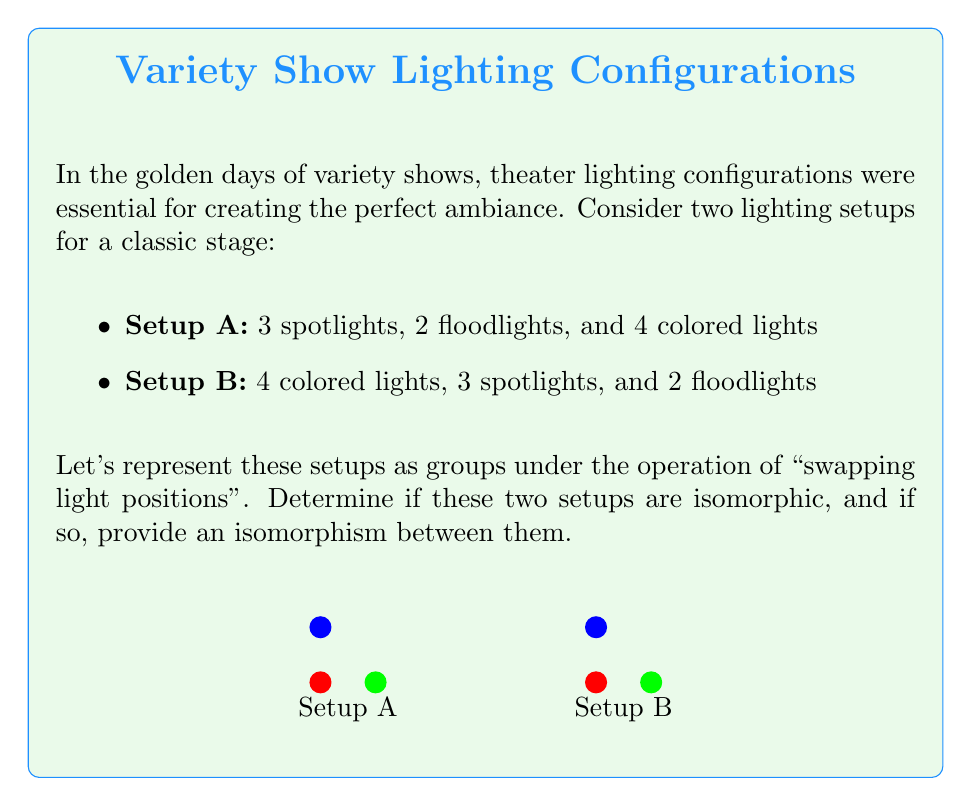Give your solution to this math problem. Let's approach this step-by-step:

1) First, we need to understand what these groups represent:
   - Setup A: $S_3 \times S_2 \times S_4$
   - Setup B: $S_4 \times S_3 \times S_2$
   
   Where $S_n$ represents the symmetric group on n elements.

2) For two groups to be isomorphic, they must have the same order. Let's calculate the order of each group:
   
   Order of Setup A: $|S_3 \times S_2 \times S_4| = |S_3| \cdot |S_2| \cdot |S_4| = 3! \cdot 2! \cdot 4! = 6 \cdot 2 \cdot 24 = 288$
   
   Order of Setup B: $|S_4 \times S_3 \times S_2| = |S_4| \cdot |S_3| \cdot |S_2| = 4! \cdot 3! \cdot 2! = 24 \cdot 6 \cdot 2 = 288$

3) The orders are the same, which is a necessary condition for isomorphism. In this case, it's also sufficient because we're dealing with direct products of symmetric groups.

4) To construct an isomorphism $\phi: A \to B$, we can map:
   
   $\phi((a,b,c)) = (c,a,b)$ for $a \in S_3$, $b \in S_2$, $c \in S_4$

5) This map is bijective and preserves the group operation (swapping lights), making it an isomorphism.
Answer: Yes, isomorphic. $\phi((a,b,c)) = (c,a,b)$ 